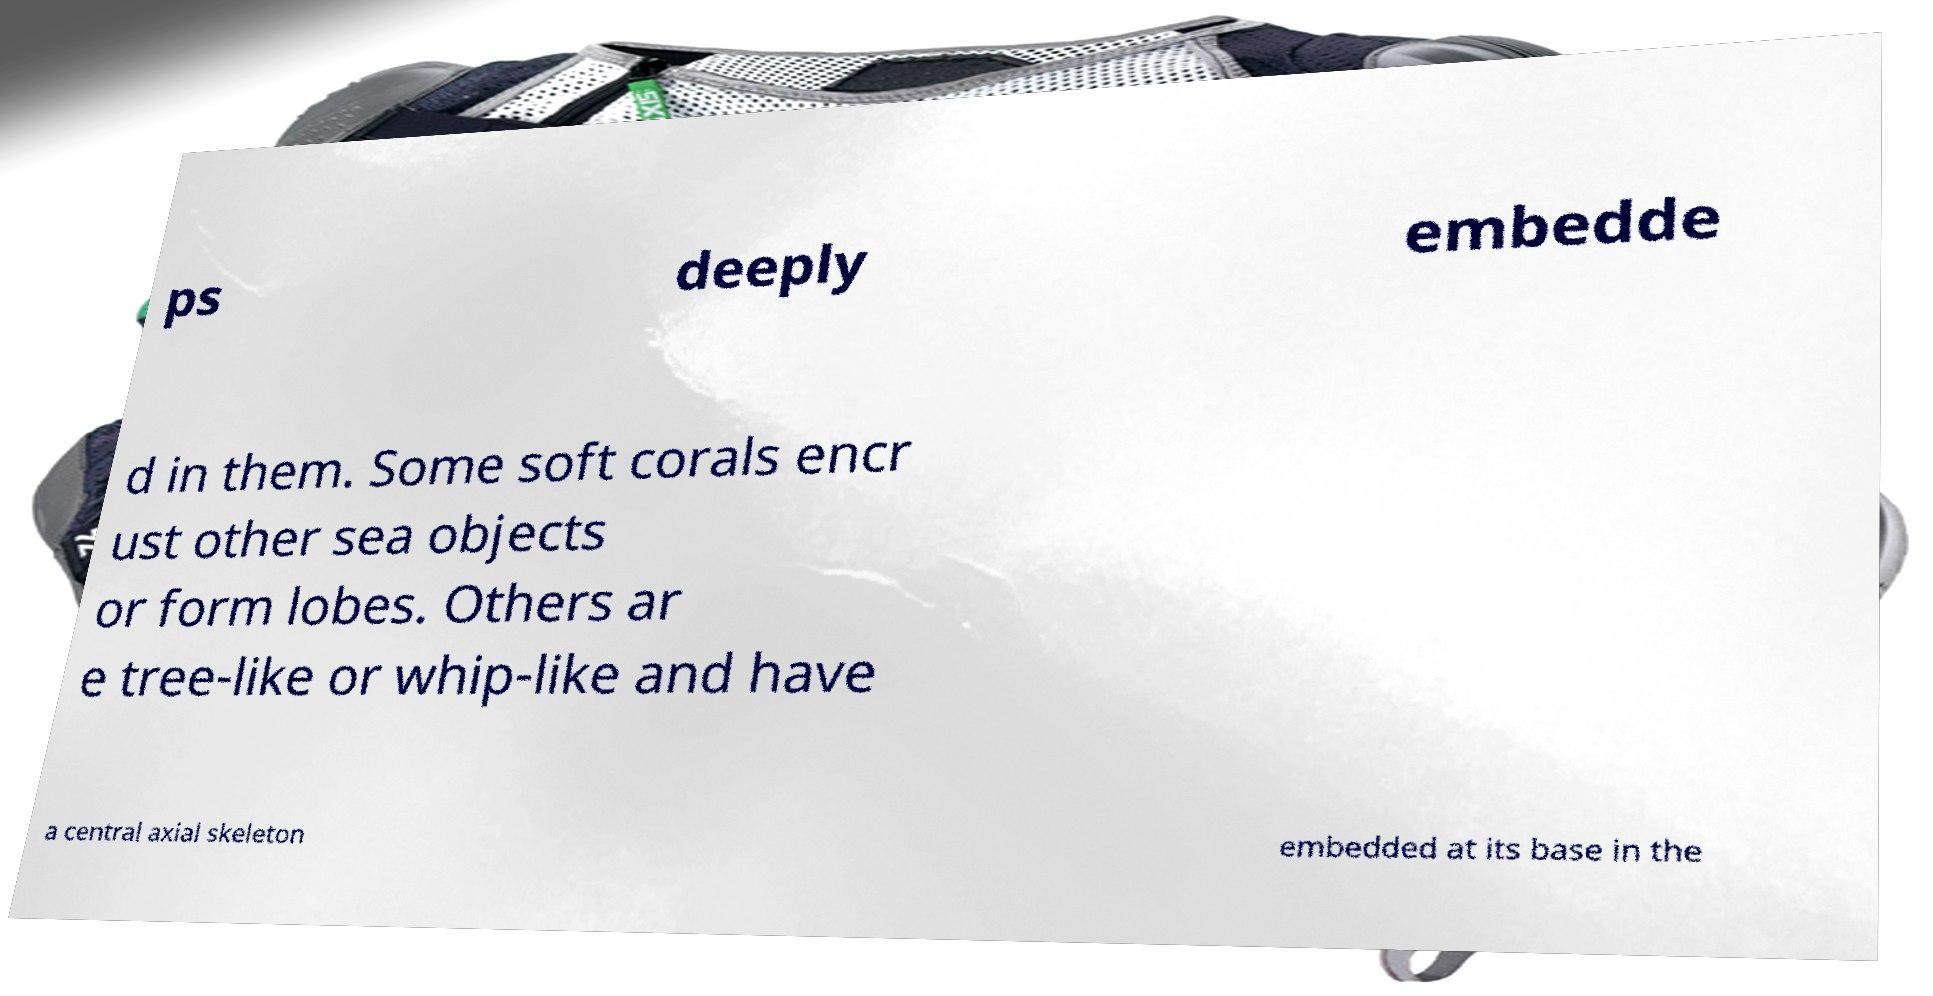For documentation purposes, I need the text within this image transcribed. Could you provide that? ps deeply embedde d in them. Some soft corals encr ust other sea objects or form lobes. Others ar e tree-like or whip-like and have a central axial skeleton embedded at its base in the 